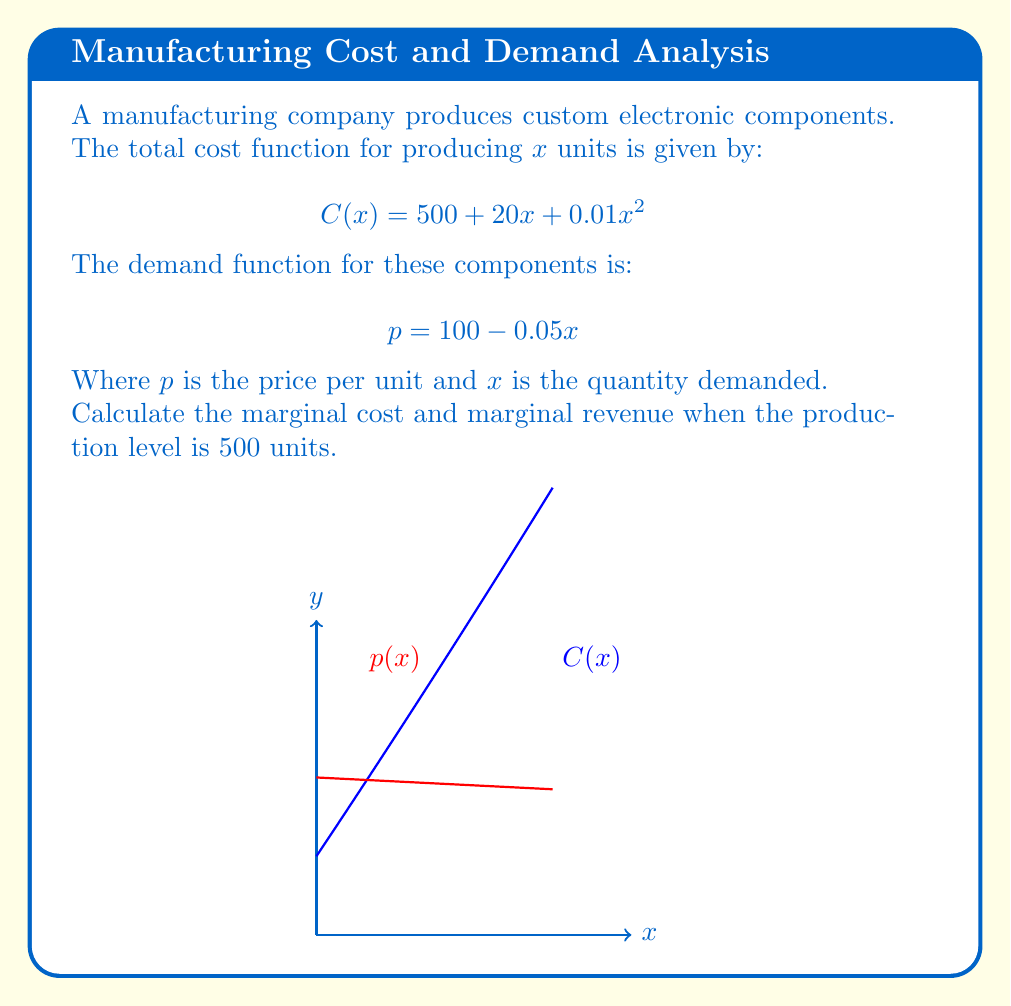Provide a solution to this math problem. 1. Marginal Cost (MC):
   The marginal cost is the derivative of the total cost function with respect to x.
   $$MC = \frac{d}{dx}C(x) = \frac{d}{dx}(500 + 20x + 0.01x^2)$$
   $$MC = 20 + 0.02x$$

   At x = 500:
   $$MC = 20 + 0.02(500) = 30$$

2. Marginal Revenue (MR):
   First, we need to find the total revenue function R(x).
   $$R(x) = px = (100 - 0.05x)x = 100x - 0.05x^2$$

   Now, we can find the marginal revenue by differentiating R(x):
   $$MR = \frac{d}{dx}R(x) = \frac{d}{dx}(100x - 0.05x^2)$$
   $$MR = 100 - 0.1x$$

   At x = 500:
   $$MR = 100 - 0.1(500) = 50$$
Answer: Marginal Cost: $30, Marginal Revenue: $50 